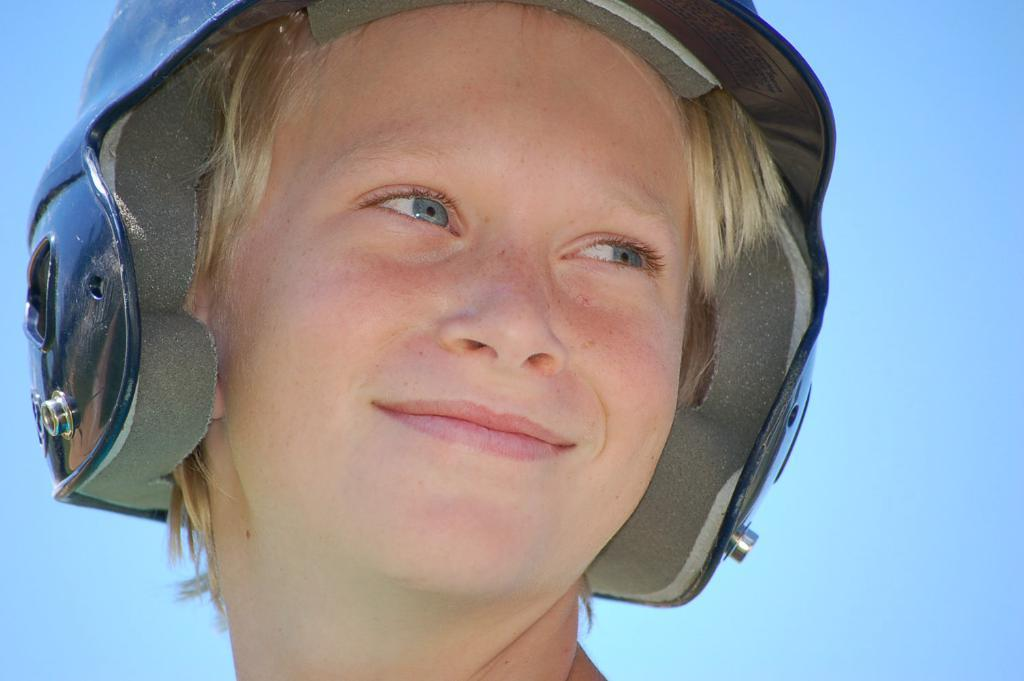What is the main subject of the image? There is a person in the image. What is the person wearing on their head? The person is wearing a helmet. What can be seen in the background of the image? The background of the image is a blue sky. Who is the owner of the beast in the image? There is no beast present in the image, so it is not possible to determine the owner. 